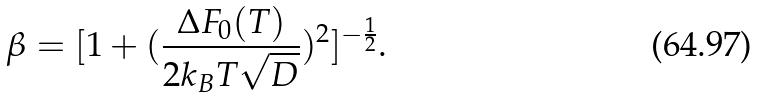<formula> <loc_0><loc_0><loc_500><loc_500>\beta = [ 1 + ( \frac { \Delta F _ { 0 } ( T ) } { 2 k _ { B } T \sqrt { D } } ) ^ { 2 } ] ^ { - \frac { 1 } { 2 } } .</formula> 